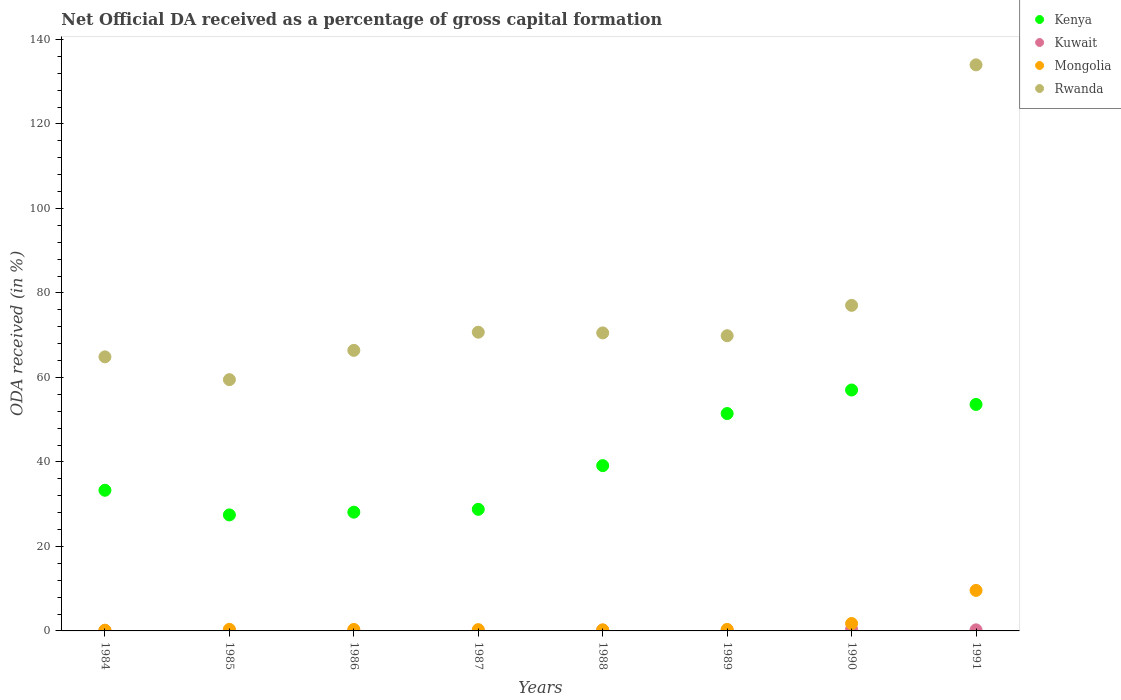How many different coloured dotlines are there?
Offer a terse response. 4. Is the number of dotlines equal to the number of legend labels?
Your answer should be compact. Yes. What is the net ODA received in Kuwait in 1990?
Keep it short and to the point. 0.4. Across all years, what is the maximum net ODA received in Kuwait?
Your answer should be very brief. 0.4. Across all years, what is the minimum net ODA received in Kenya?
Make the answer very short. 27.46. What is the total net ODA received in Kuwait in the graph?
Offer a very short reply. 1.41. What is the difference between the net ODA received in Kuwait in 1984 and that in 1991?
Offer a very short reply. -0.16. What is the difference between the net ODA received in Rwanda in 1989 and the net ODA received in Kuwait in 1986?
Offer a terse response. 69.75. What is the average net ODA received in Kenya per year?
Ensure brevity in your answer.  39.86. In the year 1988, what is the difference between the net ODA received in Kenya and net ODA received in Rwanda?
Offer a terse response. -31.42. What is the ratio of the net ODA received in Rwanda in 1984 to that in 1986?
Offer a very short reply. 0.98. Is the net ODA received in Kenya in 1984 less than that in 1988?
Keep it short and to the point. Yes. Is the difference between the net ODA received in Kenya in 1988 and 1990 greater than the difference between the net ODA received in Rwanda in 1988 and 1990?
Provide a short and direct response. No. What is the difference between the highest and the second highest net ODA received in Kenya?
Your answer should be very brief. 3.41. What is the difference between the highest and the lowest net ODA received in Kenya?
Keep it short and to the point. 29.57. In how many years, is the net ODA received in Kuwait greater than the average net ODA received in Kuwait taken over all years?
Give a very brief answer. 3. Is the sum of the net ODA received in Kenya in 1986 and 1991 greater than the maximum net ODA received in Rwanda across all years?
Your answer should be compact. No. Is it the case that in every year, the sum of the net ODA received in Mongolia and net ODA received in Kenya  is greater than the net ODA received in Rwanda?
Give a very brief answer. No. How many dotlines are there?
Give a very brief answer. 4. How many years are there in the graph?
Provide a short and direct response. 8. Are the values on the major ticks of Y-axis written in scientific E-notation?
Your answer should be compact. No. Does the graph contain any zero values?
Give a very brief answer. No. Does the graph contain grids?
Give a very brief answer. No. Where does the legend appear in the graph?
Provide a succinct answer. Top right. How are the legend labels stacked?
Offer a terse response. Vertical. What is the title of the graph?
Your answer should be compact. Net Official DA received as a percentage of gross capital formation. Does "Gambia, The" appear as one of the legend labels in the graph?
Keep it short and to the point. No. What is the label or title of the Y-axis?
Provide a succinct answer. ODA received (in %). What is the ODA received (in %) of Kenya in 1984?
Offer a terse response. 33.3. What is the ODA received (in %) of Kuwait in 1984?
Offer a terse response. 0.1. What is the ODA received (in %) in Mongolia in 1984?
Your answer should be compact. 0.17. What is the ODA received (in %) in Rwanda in 1984?
Ensure brevity in your answer.  64.87. What is the ODA received (in %) of Kenya in 1985?
Your response must be concise. 27.46. What is the ODA received (in %) in Kuwait in 1985?
Make the answer very short. 0.1. What is the ODA received (in %) of Mongolia in 1985?
Ensure brevity in your answer.  0.38. What is the ODA received (in %) of Rwanda in 1985?
Provide a short and direct response. 59.48. What is the ODA received (in %) in Kenya in 1986?
Your response must be concise. 28.11. What is the ODA received (in %) in Kuwait in 1986?
Offer a terse response. 0.13. What is the ODA received (in %) in Mongolia in 1986?
Offer a very short reply. 0.35. What is the ODA received (in %) of Rwanda in 1986?
Ensure brevity in your answer.  66.41. What is the ODA received (in %) in Kenya in 1987?
Your answer should be compact. 28.78. What is the ODA received (in %) of Kuwait in 1987?
Offer a terse response. 0.09. What is the ODA received (in %) of Mongolia in 1987?
Make the answer very short. 0.3. What is the ODA received (in %) in Rwanda in 1987?
Offer a terse response. 70.71. What is the ODA received (in %) of Kenya in 1988?
Your answer should be compact. 39.13. What is the ODA received (in %) in Kuwait in 1988?
Provide a short and direct response. 0.18. What is the ODA received (in %) of Mongolia in 1988?
Your response must be concise. 0.26. What is the ODA received (in %) in Rwanda in 1988?
Your response must be concise. 70.55. What is the ODA received (in %) of Kenya in 1989?
Your answer should be very brief. 51.46. What is the ODA received (in %) in Kuwait in 1989?
Provide a short and direct response. 0.16. What is the ODA received (in %) of Mongolia in 1989?
Provide a succinct answer. 0.36. What is the ODA received (in %) of Rwanda in 1989?
Give a very brief answer. 69.88. What is the ODA received (in %) of Kenya in 1990?
Give a very brief answer. 57.03. What is the ODA received (in %) of Kuwait in 1990?
Give a very brief answer. 0.4. What is the ODA received (in %) in Mongolia in 1990?
Keep it short and to the point. 1.75. What is the ODA received (in %) in Rwanda in 1990?
Provide a succinct answer. 77.07. What is the ODA received (in %) of Kenya in 1991?
Offer a very short reply. 53.61. What is the ODA received (in %) in Kuwait in 1991?
Ensure brevity in your answer.  0.26. What is the ODA received (in %) of Mongolia in 1991?
Your response must be concise. 9.59. What is the ODA received (in %) of Rwanda in 1991?
Offer a terse response. 134. Across all years, what is the maximum ODA received (in %) in Kenya?
Offer a terse response. 57.03. Across all years, what is the maximum ODA received (in %) of Kuwait?
Keep it short and to the point. 0.4. Across all years, what is the maximum ODA received (in %) of Mongolia?
Provide a short and direct response. 9.59. Across all years, what is the maximum ODA received (in %) of Rwanda?
Provide a succinct answer. 134. Across all years, what is the minimum ODA received (in %) of Kenya?
Offer a very short reply. 27.46. Across all years, what is the minimum ODA received (in %) of Kuwait?
Make the answer very short. 0.09. Across all years, what is the minimum ODA received (in %) in Mongolia?
Offer a terse response. 0.17. Across all years, what is the minimum ODA received (in %) in Rwanda?
Offer a very short reply. 59.48. What is the total ODA received (in %) in Kenya in the graph?
Make the answer very short. 318.88. What is the total ODA received (in %) in Kuwait in the graph?
Your response must be concise. 1.41. What is the total ODA received (in %) in Mongolia in the graph?
Keep it short and to the point. 13.16. What is the total ODA received (in %) in Rwanda in the graph?
Make the answer very short. 612.96. What is the difference between the ODA received (in %) in Kenya in 1984 and that in 1985?
Your response must be concise. 5.84. What is the difference between the ODA received (in %) of Kuwait in 1984 and that in 1985?
Keep it short and to the point. -0.01. What is the difference between the ODA received (in %) in Mongolia in 1984 and that in 1985?
Offer a very short reply. -0.2. What is the difference between the ODA received (in %) of Rwanda in 1984 and that in 1985?
Offer a terse response. 5.4. What is the difference between the ODA received (in %) of Kenya in 1984 and that in 1986?
Ensure brevity in your answer.  5.19. What is the difference between the ODA received (in %) of Kuwait in 1984 and that in 1986?
Give a very brief answer. -0.03. What is the difference between the ODA received (in %) of Mongolia in 1984 and that in 1986?
Ensure brevity in your answer.  -0.18. What is the difference between the ODA received (in %) of Rwanda in 1984 and that in 1986?
Make the answer very short. -1.54. What is the difference between the ODA received (in %) in Kenya in 1984 and that in 1987?
Provide a succinct answer. 4.52. What is the difference between the ODA received (in %) in Kuwait in 1984 and that in 1987?
Your answer should be very brief. 0.01. What is the difference between the ODA received (in %) in Mongolia in 1984 and that in 1987?
Keep it short and to the point. -0.13. What is the difference between the ODA received (in %) in Rwanda in 1984 and that in 1987?
Keep it short and to the point. -5.84. What is the difference between the ODA received (in %) in Kenya in 1984 and that in 1988?
Make the answer very short. -5.83. What is the difference between the ODA received (in %) of Kuwait in 1984 and that in 1988?
Offer a very short reply. -0.08. What is the difference between the ODA received (in %) in Mongolia in 1984 and that in 1988?
Offer a terse response. -0.08. What is the difference between the ODA received (in %) in Rwanda in 1984 and that in 1988?
Your answer should be very brief. -5.67. What is the difference between the ODA received (in %) in Kenya in 1984 and that in 1989?
Your answer should be compact. -18.16. What is the difference between the ODA received (in %) of Kuwait in 1984 and that in 1989?
Your answer should be compact. -0.06. What is the difference between the ODA received (in %) of Mongolia in 1984 and that in 1989?
Provide a succinct answer. -0.18. What is the difference between the ODA received (in %) of Rwanda in 1984 and that in 1989?
Offer a very short reply. -5. What is the difference between the ODA received (in %) in Kenya in 1984 and that in 1990?
Provide a short and direct response. -23.73. What is the difference between the ODA received (in %) in Kuwait in 1984 and that in 1990?
Your response must be concise. -0.3. What is the difference between the ODA received (in %) of Mongolia in 1984 and that in 1990?
Your answer should be compact. -1.58. What is the difference between the ODA received (in %) in Rwanda in 1984 and that in 1990?
Your answer should be very brief. -12.19. What is the difference between the ODA received (in %) in Kenya in 1984 and that in 1991?
Offer a very short reply. -20.31. What is the difference between the ODA received (in %) of Kuwait in 1984 and that in 1991?
Give a very brief answer. -0.16. What is the difference between the ODA received (in %) in Mongolia in 1984 and that in 1991?
Provide a short and direct response. -9.41. What is the difference between the ODA received (in %) in Rwanda in 1984 and that in 1991?
Keep it short and to the point. -69.12. What is the difference between the ODA received (in %) of Kenya in 1985 and that in 1986?
Provide a succinct answer. -0.65. What is the difference between the ODA received (in %) in Kuwait in 1985 and that in 1986?
Offer a very short reply. -0.02. What is the difference between the ODA received (in %) of Mongolia in 1985 and that in 1986?
Your answer should be very brief. 0.02. What is the difference between the ODA received (in %) in Rwanda in 1985 and that in 1986?
Ensure brevity in your answer.  -6.93. What is the difference between the ODA received (in %) of Kenya in 1985 and that in 1987?
Your response must be concise. -1.32. What is the difference between the ODA received (in %) of Kuwait in 1985 and that in 1987?
Ensure brevity in your answer.  0.02. What is the difference between the ODA received (in %) of Mongolia in 1985 and that in 1987?
Give a very brief answer. 0.07. What is the difference between the ODA received (in %) of Rwanda in 1985 and that in 1987?
Provide a succinct answer. -11.23. What is the difference between the ODA received (in %) of Kenya in 1985 and that in 1988?
Provide a succinct answer. -11.67. What is the difference between the ODA received (in %) of Kuwait in 1985 and that in 1988?
Offer a very short reply. -0.08. What is the difference between the ODA received (in %) in Mongolia in 1985 and that in 1988?
Keep it short and to the point. 0.12. What is the difference between the ODA received (in %) of Rwanda in 1985 and that in 1988?
Offer a terse response. -11.07. What is the difference between the ODA received (in %) of Kenya in 1985 and that in 1989?
Offer a terse response. -24. What is the difference between the ODA received (in %) of Kuwait in 1985 and that in 1989?
Your answer should be compact. -0.05. What is the difference between the ODA received (in %) of Mongolia in 1985 and that in 1989?
Keep it short and to the point. 0.02. What is the difference between the ODA received (in %) of Rwanda in 1985 and that in 1989?
Give a very brief answer. -10.4. What is the difference between the ODA received (in %) of Kenya in 1985 and that in 1990?
Your answer should be very brief. -29.57. What is the difference between the ODA received (in %) of Kuwait in 1985 and that in 1990?
Ensure brevity in your answer.  -0.29. What is the difference between the ODA received (in %) of Mongolia in 1985 and that in 1990?
Provide a short and direct response. -1.38. What is the difference between the ODA received (in %) of Rwanda in 1985 and that in 1990?
Offer a terse response. -17.59. What is the difference between the ODA received (in %) of Kenya in 1985 and that in 1991?
Provide a short and direct response. -26.15. What is the difference between the ODA received (in %) in Kuwait in 1985 and that in 1991?
Your response must be concise. -0.15. What is the difference between the ODA received (in %) of Mongolia in 1985 and that in 1991?
Give a very brief answer. -9.21. What is the difference between the ODA received (in %) in Rwanda in 1985 and that in 1991?
Provide a short and direct response. -74.52. What is the difference between the ODA received (in %) of Kenya in 1986 and that in 1987?
Your answer should be very brief. -0.67. What is the difference between the ODA received (in %) of Kuwait in 1986 and that in 1987?
Offer a very short reply. 0.04. What is the difference between the ODA received (in %) in Mongolia in 1986 and that in 1987?
Your answer should be compact. 0.05. What is the difference between the ODA received (in %) in Rwanda in 1986 and that in 1987?
Give a very brief answer. -4.3. What is the difference between the ODA received (in %) of Kenya in 1986 and that in 1988?
Provide a short and direct response. -11.02. What is the difference between the ODA received (in %) in Kuwait in 1986 and that in 1988?
Provide a short and direct response. -0.06. What is the difference between the ODA received (in %) in Mongolia in 1986 and that in 1988?
Give a very brief answer. 0.1. What is the difference between the ODA received (in %) of Rwanda in 1986 and that in 1988?
Offer a very short reply. -4.13. What is the difference between the ODA received (in %) in Kenya in 1986 and that in 1989?
Provide a short and direct response. -23.35. What is the difference between the ODA received (in %) of Kuwait in 1986 and that in 1989?
Ensure brevity in your answer.  -0.03. What is the difference between the ODA received (in %) in Mongolia in 1986 and that in 1989?
Ensure brevity in your answer.  -0. What is the difference between the ODA received (in %) of Rwanda in 1986 and that in 1989?
Your response must be concise. -3.46. What is the difference between the ODA received (in %) in Kenya in 1986 and that in 1990?
Offer a terse response. -28.92. What is the difference between the ODA received (in %) in Kuwait in 1986 and that in 1990?
Give a very brief answer. -0.27. What is the difference between the ODA received (in %) of Mongolia in 1986 and that in 1990?
Give a very brief answer. -1.4. What is the difference between the ODA received (in %) in Rwanda in 1986 and that in 1990?
Provide a short and direct response. -10.65. What is the difference between the ODA received (in %) of Kenya in 1986 and that in 1991?
Provide a short and direct response. -25.5. What is the difference between the ODA received (in %) of Kuwait in 1986 and that in 1991?
Offer a terse response. -0.13. What is the difference between the ODA received (in %) in Mongolia in 1986 and that in 1991?
Provide a succinct answer. -9.24. What is the difference between the ODA received (in %) in Rwanda in 1986 and that in 1991?
Offer a very short reply. -67.58. What is the difference between the ODA received (in %) of Kenya in 1987 and that in 1988?
Your answer should be very brief. -10.35. What is the difference between the ODA received (in %) in Kuwait in 1987 and that in 1988?
Make the answer very short. -0.1. What is the difference between the ODA received (in %) in Mongolia in 1987 and that in 1988?
Your answer should be very brief. 0.05. What is the difference between the ODA received (in %) of Rwanda in 1987 and that in 1988?
Keep it short and to the point. 0.17. What is the difference between the ODA received (in %) in Kenya in 1987 and that in 1989?
Offer a very short reply. -22.68. What is the difference between the ODA received (in %) in Kuwait in 1987 and that in 1989?
Keep it short and to the point. -0.07. What is the difference between the ODA received (in %) in Mongolia in 1987 and that in 1989?
Make the answer very short. -0.05. What is the difference between the ODA received (in %) in Rwanda in 1987 and that in 1989?
Your answer should be very brief. 0.83. What is the difference between the ODA received (in %) in Kenya in 1987 and that in 1990?
Your answer should be very brief. -28.25. What is the difference between the ODA received (in %) of Kuwait in 1987 and that in 1990?
Ensure brevity in your answer.  -0.31. What is the difference between the ODA received (in %) in Mongolia in 1987 and that in 1990?
Provide a succinct answer. -1.45. What is the difference between the ODA received (in %) in Rwanda in 1987 and that in 1990?
Offer a very short reply. -6.36. What is the difference between the ODA received (in %) of Kenya in 1987 and that in 1991?
Give a very brief answer. -24.83. What is the difference between the ODA received (in %) of Kuwait in 1987 and that in 1991?
Your answer should be very brief. -0.17. What is the difference between the ODA received (in %) in Mongolia in 1987 and that in 1991?
Provide a succinct answer. -9.28. What is the difference between the ODA received (in %) in Rwanda in 1987 and that in 1991?
Ensure brevity in your answer.  -63.28. What is the difference between the ODA received (in %) in Kenya in 1988 and that in 1989?
Provide a short and direct response. -12.33. What is the difference between the ODA received (in %) of Kuwait in 1988 and that in 1989?
Your answer should be compact. 0.03. What is the difference between the ODA received (in %) of Mongolia in 1988 and that in 1989?
Give a very brief answer. -0.1. What is the difference between the ODA received (in %) of Rwanda in 1988 and that in 1989?
Give a very brief answer. 0.67. What is the difference between the ODA received (in %) of Kenya in 1988 and that in 1990?
Give a very brief answer. -17.9. What is the difference between the ODA received (in %) in Kuwait in 1988 and that in 1990?
Offer a very short reply. -0.21. What is the difference between the ODA received (in %) in Mongolia in 1988 and that in 1990?
Your answer should be very brief. -1.5. What is the difference between the ODA received (in %) of Rwanda in 1988 and that in 1990?
Provide a short and direct response. -6.52. What is the difference between the ODA received (in %) in Kenya in 1988 and that in 1991?
Offer a very short reply. -14.48. What is the difference between the ODA received (in %) of Kuwait in 1988 and that in 1991?
Offer a very short reply. -0.07. What is the difference between the ODA received (in %) in Mongolia in 1988 and that in 1991?
Make the answer very short. -9.33. What is the difference between the ODA received (in %) of Rwanda in 1988 and that in 1991?
Keep it short and to the point. -63.45. What is the difference between the ODA received (in %) of Kenya in 1989 and that in 1990?
Provide a short and direct response. -5.57. What is the difference between the ODA received (in %) in Kuwait in 1989 and that in 1990?
Ensure brevity in your answer.  -0.24. What is the difference between the ODA received (in %) in Mongolia in 1989 and that in 1990?
Offer a very short reply. -1.4. What is the difference between the ODA received (in %) in Rwanda in 1989 and that in 1990?
Give a very brief answer. -7.19. What is the difference between the ODA received (in %) of Kenya in 1989 and that in 1991?
Make the answer very short. -2.15. What is the difference between the ODA received (in %) in Kuwait in 1989 and that in 1991?
Provide a short and direct response. -0.1. What is the difference between the ODA received (in %) in Mongolia in 1989 and that in 1991?
Your answer should be very brief. -9.23. What is the difference between the ODA received (in %) in Rwanda in 1989 and that in 1991?
Ensure brevity in your answer.  -64.12. What is the difference between the ODA received (in %) of Kenya in 1990 and that in 1991?
Provide a succinct answer. 3.41. What is the difference between the ODA received (in %) of Kuwait in 1990 and that in 1991?
Offer a terse response. 0.14. What is the difference between the ODA received (in %) in Mongolia in 1990 and that in 1991?
Your answer should be compact. -7.84. What is the difference between the ODA received (in %) of Rwanda in 1990 and that in 1991?
Offer a very short reply. -56.93. What is the difference between the ODA received (in %) in Kenya in 1984 and the ODA received (in %) in Kuwait in 1985?
Offer a terse response. 33.19. What is the difference between the ODA received (in %) in Kenya in 1984 and the ODA received (in %) in Mongolia in 1985?
Provide a short and direct response. 32.92. What is the difference between the ODA received (in %) of Kenya in 1984 and the ODA received (in %) of Rwanda in 1985?
Offer a terse response. -26.18. What is the difference between the ODA received (in %) in Kuwait in 1984 and the ODA received (in %) in Mongolia in 1985?
Your response must be concise. -0.28. What is the difference between the ODA received (in %) of Kuwait in 1984 and the ODA received (in %) of Rwanda in 1985?
Your answer should be very brief. -59.38. What is the difference between the ODA received (in %) of Mongolia in 1984 and the ODA received (in %) of Rwanda in 1985?
Keep it short and to the point. -59.3. What is the difference between the ODA received (in %) in Kenya in 1984 and the ODA received (in %) in Kuwait in 1986?
Ensure brevity in your answer.  33.17. What is the difference between the ODA received (in %) in Kenya in 1984 and the ODA received (in %) in Mongolia in 1986?
Make the answer very short. 32.95. What is the difference between the ODA received (in %) of Kenya in 1984 and the ODA received (in %) of Rwanda in 1986?
Provide a succinct answer. -33.12. What is the difference between the ODA received (in %) in Kuwait in 1984 and the ODA received (in %) in Mongolia in 1986?
Offer a very short reply. -0.25. What is the difference between the ODA received (in %) in Kuwait in 1984 and the ODA received (in %) in Rwanda in 1986?
Provide a succinct answer. -66.32. What is the difference between the ODA received (in %) in Mongolia in 1984 and the ODA received (in %) in Rwanda in 1986?
Keep it short and to the point. -66.24. What is the difference between the ODA received (in %) of Kenya in 1984 and the ODA received (in %) of Kuwait in 1987?
Offer a terse response. 33.21. What is the difference between the ODA received (in %) in Kenya in 1984 and the ODA received (in %) in Mongolia in 1987?
Provide a succinct answer. 32.99. What is the difference between the ODA received (in %) in Kenya in 1984 and the ODA received (in %) in Rwanda in 1987?
Offer a terse response. -37.41. What is the difference between the ODA received (in %) of Kuwait in 1984 and the ODA received (in %) of Mongolia in 1987?
Provide a short and direct response. -0.21. What is the difference between the ODA received (in %) in Kuwait in 1984 and the ODA received (in %) in Rwanda in 1987?
Your answer should be compact. -70.61. What is the difference between the ODA received (in %) in Mongolia in 1984 and the ODA received (in %) in Rwanda in 1987?
Provide a short and direct response. -70.54. What is the difference between the ODA received (in %) in Kenya in 1984 and the ODA received (in %) in Kuwait in 1988?
Make the answer very short. 33.12. What is the difference between the ODA received (in %) in Kenya in 1984 and the ODA received (in %) in Mongolia in 1988?
Offer a very short reply. 33.04. What is the difference between the ODA received (in %) in Kenya in 1984 and the ODA received (in %) in Rwanda in 1988?
Offer a very short reply. -37.25. What is the difference between the ODA received (in %) of Kuwait in 1984 and the ODA received (in %) of Mongolia in 1988?
Ensure brevity in your answer.  -0.16. What is the difference between the ODA received (in %) in Kuwait in 1984 and the ODA received (in %) in Rwanda in 1988?
Your answer should be compact. -70.45. What is the difference between the ODA received (in %) of Mongolia in 1984 and the ODA received (in %) of Rwanda in 1988?
Your answer should be very brief. -70.37. What is the difference between the ODA received (in %) in Kenya in 1984 and the ODA received (in %) in Kuwait in 1989?
Offer a very short reply. 33.14. What is the difference between the ODA received (in %) of Kenya in 1984 and the ODA received (in %) of Mongolia in 1989?
Keep it short and to the point. 32.94. What is the difference between the ODA received (in %) in Kenya in 1984 and the ODA received (in %) in Rwanda in 1989?
Offer a very short reply. -36.58. What is the difference between the ODA received (in %) in Kuwait in 1984 and the ODA received (in %) in Mongolia in 1989?
Provide a succinct answer. -0.26. What is the difference between the ODA received (in %) of Kuwait in 1984 and the ODA received (in %) of Rwanda in 1989?
Provide a succinct answer. -69.78. What is the difference between the ODA received (in %) of Mongolia in 1984 and the ODA received (in %) of Rwanda in 1989?
Your answer should be compact. -69.7. What is the difference between the ODA received (in %) in Kenya in 1984 and the ODA received (in %) in Kuwait in 1990?
Provide a succinct answer. 32.9. What is the difference between the ODA received (in %) in Kenya in 1984 and the ODA received (in %) in Mongolia in 1990?
Provide a succinct answer. 31.54. What is the difference between the ODA received (in %) in Kenya in 1984 and the ODA received (in %) in Rwanda in 1990?
Make the answer very short. -43.77. What is the difference between the ODA received (in %) in Kuwait in 1984 and the ODA received (in %) in Mongolia in 1990?
Keep it short and to the point. -1.66. What is the difference between the ODA received (in %) of Kuwait in 1984 and the ODA received (in %) of Rwanda in 1990?
Your answer should be very brief. -76.97. What is the difference between the ODA received (in %) of Mongolia in 1984 and the ODA received (in %) of Rwanda in 1990?
Your answer should be very brief. -76.89. What is the difference between the ODA received (in %) in Kenya in 1984 and the ODA received (in %) in Kuwait in 1991?
Provide a succinct answer. 33.04. What is the difference between the ODA received (in %) of Kenya in 1984 and the ODA received (in %) of Mongolia in 1991?
Offer a very short reply. 23.71. What is the difference between the ODA received (in %) of Kenya in 1984 and the ODA received (in %) of Rwanda in 1991?
Keep it short and to the point. -100.7. What is the difference between the ODA received (in %) of Kuwait in 1984 and the ODA received (in %) of Mongolia in 1991?
Make the answer very short. -9.49. What is the difference between the ODA received (in %) in Kuwait in 1984 and the ODA received (in %) in Rwanda in 1991?
Keep it short and to the point. -133.9. What is the difference between the ODA received (in %) of Mongolia in 1984 and the ODA received (in %) of Rwanda in 1991?
Give a very brief answer. -133.82. What is the difference between the ODA received (in %) in Kenya in 1985 and the ODA received (in %) in Kuwait in 1986?
Your response must be concise. 27.34. What is the difference between the ODA received (in %) of Kenya in 1985 and the ODA received (in %) of Mongolia in 1986?
Your response must be concise. 27.11. What is the difference between the ODA received (in %) in Kenya in 1985 and the ODA received (in %) in Rwanda in 1986?
Give a very brief answer. -38.95. What is the difference between the ODA received (in %) in Kuwait in 1985 and the ODA received (in %) in Mongolia in 1986?
Your answer should be compact. -0.25. What is the difference between the ODA received (in %) in Kuwait in 1985 and the ODA received (in %) in Rwanda in 1986?
Offer a very short reply. -66.31. What is the difference between the ODA received (in %) in Mongolia in 1985 and the ODA received (in %) in Rwanda in 1986?
Your answer should be compact. -66.04. What is the difference between the ODA received (in %) in Kenya in 1985 and the ODA received (in %) in Kuwait in 1987?
Offer a very short reply. 27.37. What is the difference between the ODA received (in %) of Kenya in 1985 and the ODA received (in %) of Mongolia in 1987?
Give a very brief answer. 27.16. What is the difference between the ODA received (in %) in Kenya in 1985 and the ODA received (in %) in Rwanda in 1987?
Give a very brief answer. -43.25. What is the difference between the ODA received (in %) of Kuwait in 1985 and the ODA received (in %) of Mongolia in 1987?
Provide a short and direct response. -0.2. What is the difference between the ODA received (in %) of Kuwait in 1985 and the ODA received (in %) of Rwanda in 1987?
Ensure brevity in your answer.  -70.61. What is the difference between the ODA received (in %) in Mongolia in 1985 and the ODA received (in %) in Rwanda in 1987?
Ensure brevity in your answer.  -70.33. What is the difference between the ODA received (in %) of Kenya in 1985 and the ODA received (in %) of Kuwait in 1988?
Your answer should be compact. 27.28. What is the difference between the ODA received (in %) of Kenya in 1985 and the ODA received (in %) of Mongolia in 1988?
Give a very brief answer. 27.21. What is the difference between the ODA received (in %) of Kenya in 1985 and the ODA received (in %) of Rwanda in 1988?
Your answer should be very brief. -43.08. What is the difference between the ODA received (in %) in Kuwait in 1985 and the ODA received (in %) in Mongolia in 1988?
Offer a terse response. -0.15. What is the difference between the ODA received (in %) in Kuwait in 1985 and the ODA received (in %) in Rwanda in 1988?
Provide a succinct answer. -70.44. What is the difference between the ODA received (in %) in Mongolia in 1985 and the ODA received (in %) in Rwanda in 1988?
Make the answer very short. -70.17. What is the difference between the ODA received (in %) of Kenya in 1985 and the ODA received (in %) of Kuwait in 1989?
Offer a very short reply. 27.3. What is the difference between the ODA received (in %) of Kenya in 1985 and the ODA received (in %) of Mongolia in 1989?
Your response must be concise. 27.11. What is the difference between the ODA received (in %) of Kenya in 1985 and the ODA received (in %) of Rwanda in 1989?
Your answer should be compact. -42.42. What is the difference between the ODA received (in %) in Kuwait in 1985 and the ODA received (in %) in Mongolia in 1989?
Your response must be concise. -0.25. What is the difference between the ODA received (in %) of Kuwait in 1985 and the ODA received (in %) of Rwanda in 1989?
Make the answer very short. -69.77. What is the difference between the ODA received (in %) in Mongolia in 1985 and the ODA received (in %) in Rwanda in 1989?
Your answer should be very brief. -69.5. What is the difference between the ODA received (in %) in Kenya in 1985 and the ODA received (in %) in Kuwait in 1990?
Offer a very short reply. 27.07. What is the difference between the ODA received (in %) of Kenya in 1985 and the ODA received (in %) of Mongolia in 1990?
Offer a very short reply. 25.71. What is the difference between the ODA received (in %) of Kenya in 1985 and the ODA received (in %) of Rwanda in 1990?
Offer a very short reply. -49.6. What is the difference between the ODA received (in %) of Kuwait in 1985 and the ODA received (in %) of Mongolia in 1990?
Make the answer very short. -1.65. What is the difference between the ODA received (in %) in Kuwait in 1985 and the ODA received (in %) in Rwanda in 1990?
Your response must be concise. -76.96. What is the difference between the ODA received (in %) of Mongolia in 1985 and the ODA received (in %) of Rwanda in 1990?
Your answer should be compact. -76.69. What is the difference between the ODA received (in %) in Kenya in 1985 and the ODA received (in %) in Kuwait in 1991?
Make the answer very short. 27.21. What is the difference between the ODA received (in %) of Kenya in 1985 and the ODA received (in %) of Mongolia in 1991?
Give a very brief answer. 17.87. What is the difference between the ODA received (in %) of Kenya in 1985 and the ODA received (in %) of Rwanda in 1991?
Provide a succinct answer. -106.53. What is the difference between the ODA received (in %) in Kuwait in 1985 and the ODA received (in %) in Mongolia in 1991?
Offer a very short reply. -9.49. What is the difference between the ODA received (in %) of Kuwait in 1985 and the ODA received (in %) of Rwanda in 1991?
Offer a very short reply. -133.89. What is the difference between the ODA received (in %) in Mongolia in 1985 and the ODA received (in %) in Rwanda in 1991?
Give a very brief answer. -133.62. What is the difference between the ODA received (in %) in Kenya in 1986 and the ODA received (in %) in Kuwait in 1987?
Provide a succinct answer. 28.02. What is the difference between the ODA received (in %) of Kenya in 1986 and the ODA received (in %) of Mongolia in 1987?
Give a very brief answer. 27.81. What is the difference between the ODA received (in %) in Kenya in 1986 and the ODA received (in %) in Rwanda in 1987?
Provide a short and direct response. -42.6. What is the difference between the ODA received (in %) in Kuwait in 1986 and the ODA received (in %) in Mongolia in 1987?
Offer a terse response. -0.18. What is the difference between the ODA received (in %) in Kuwait in 1986 and the ODA received (in %) in Rwanda in 1987?
Provide a short and direct response. -70.59. What is the difference between the ODA received (in %) in Mongolia in 1986 and the ODA received (in %) in Rwanda in 1987?
Your response must be concise. -70.36. What is the difference between the ODA received (in %) in Kenya in 1986 and the ODA received (in %) in Kuwait in 1988?
Your response must be concise. 27.93. What is the difference between the ODA received (in %) in Kenya in 1986 and the ODA received (in %) in Mongolia in 1988?
Keep it short and to the point. 27.85. What is the difference between the ODA received (in %) in Kenya in 1986 and the ODA received (in %) in Rwanda in 1988?
Your answer should be very brief. -42.44. What is the difference between the ODA received (in %) of Kuwait in 1986 and the ODA received (in %) of Mongolia in 1988?
Your response must be concise. -0.13. What is the difference between the ODA received (in %) of Kuwait in 1986 and the ODA received (in %) of Rwanda in 1988?
Your response must be concise. -70.42. What is the difference between the ODA received (in %) of Mongolia in 1986 and the ODA received (in %) of Rwanda in 1988?
Your answer should be very brief. -70.19. What is the difference between the ODA received (in %) of Kenya in 1986 and the ODA received (in %) of Kuwait in 1989?
Offer a terse response. 27.95. What is the difference between the ODA received (in %) of Kenya in 1986 and the ODA received (in %) of Mongolia in 1989?
Keep it short and to the point. 27.75. What is the difference between the ODA received (in %) of Kenya in 1986 and the ODA received (in %) of Rwanda in 1989?
Give a very brief answer. -41.77. What is the difference between the ODA received (in %) in Kuwait in 1986 and the ODA received (in %) in Mongolia in 1989?
Make the answer very short. -0.23. What is the difference between the ODA received (in %) of Kuwait in 1986 and the ODA received (in %) of Rwanda in 1989?
Provide a succinct answer. -69.75. What is the difference between the ODA received (in %) of Mongolia in 1986 and the ODA received (in %) of Rwanda in 1989?
Your response must be concise. -69.52. What is the difference between the ODA received (in %) in Kenya in 1986 and the ODA received (in %) in Kuwait in 1990?
Make the answer very short. 27.71. What is the difference between the ODA received (in %) of Kenya in 1986 and the ODA received (in %) of Mongolia in 1990?
Provide a short and direct response. 26.36. What is the difference between the ODA received (in %) of Kenya in 1986 and the ODA received (in %) of Rwanda in 1990?
Your response must be concise. -48.96. What is the difference between the ODA received (in %) in Kuwait in 1986 and the ODA received (in %) in Mongolia in 1990?
Your answer should be very brief. -1.63. What is the difference between the ODA received (in %) in Kuwait in 1986 and the ODA received (in %) in Rwanda in 1990?
Give a very brief answer. -76.94. What is the difference between the ODA received (in %) of Mongolia in 1986 and the ODA received (in %) of Rwanda in 1990?
Ensure brevity in your answer.  -76.71. What is the difference between the ODA received (in %) of Kenya in 1986 and the ODA received (in %) of Kuwait in 1991?
Your answer should be very brief. 27.85. What is the difference between the ODA received (in %) in Kenya in 1986 and the ODA received (in %) in Mongolia in 1991?
Provide a succinct answer. 18.52. What is the difference between the ODA received (in %) in Kenya in 1986 and the ODA received (in %) in Rwanda in 1991?
Your answer should be compact. -105.89. What is the difference between the ODA received (in %) of Kuwait in 1986 and the ODA received (in %) of Mongolia in 1991?
Keep it short and to the point. -9.46. What is the difference between the ODA received (in %) of Kuwait in 1986 and the ODA received (in %) of Rwanda in 1991?
Keep it short and to the point. -133.87. What is the difference between the ODA received (in %) of Mongolia in 1986 and the ODA received (in %) of Rwanda in 1991?
Make the answer very short. -133.64. What is the difference between the ODA received (in %) in Kenya in 1987 and the ODA received (in %) in Kuwait in 1988?
Your answer should be very brief. 28.6. What is the difference between the ODA received (in %) in Kenya in 1987 and the ODA received (in %) in Mongolia in 1988?
Offer a terse response. 28.53. What is the difference between the ODA received (in %) of Kenya in 1987 and the ODA received (in %) of Rwanda in 1988?
Your answer should be very brief. -41.76. What is the difference between the ODA received (in %) in Kuwait in 1987 and the ODA received (in %) in Mongolia in 1988?
Your response must be concise. -0.17. What is the difference between the ODA received (in %) of Kuwait in 1987 and the ODA received (in %) of Rwanda in 1988?
Provide a succinct answer. -70.46. What is the difference between the ODA received (in %) in Mongolia in 1987 and the ODA received (in %) in Rwanda in 1988?
Keep it short and to the point. -70.24. What is the difference between the ODA received (in %) of Kenya in 1987 and the ODA received (in %) of Kuwait in 1989?
Your response must be concise. 28.62. What is the difference between the ODA received (in %) in Kenya in 1987 and the ODA received (in %) in Mongolia in 1989?
Offer a terse response. 28.42. What is the difference between the ODA received (in %) of Kenya in 1987 and the ODA received (in %) of Rwanda in 1989?
Your answer should be compact. -41.1. What is the difference between the ODA received (in %) in Kuwait in 1987 and the ODA received (in %) in Mongolia in 1989?
Your answer should be very brief. -0.27. What is the difference between the ODA received (in %) in Kuwait in 1987 and the ODA received (in %) in Rwanda in 1989?
Make the answer very short. -69.79. What is the difference between the ODA received (in %) of Mongolia in 1987 and the ODA received (in %) of Rwanda in 1989?
Your response must be concise. -69.57. What is the difference between the ODA received (in %) of Kenya in 1987 and the ODA received (in %) of Kuwait in 1990?
Your answer should be compact. 28.39. What is the difference between the ODA received (in %) of Kenya in 1987 and the ODA received (in %) of Mongolia in 1990?
Keep it short and to the point. 27.03. What is the difference between the ODA received (in %) in Kenya in 1987 and the ODA received (in %) in Rwanda in 1990?
Your response must be concise. -48.28. What is the difference between the ODA received (in %) of Kuwait in 1987 and the ODA received (in %) of Mongolia in 1990?
Make the answer very short. -1.67. What is the difference between the ODA received (in %) of Kuwait in 1987 and the ODA received (in %) of Rwanda in 1990?
Your answer should be compact. -76.98. What is the difference between the ODA received (in %) of Mongolia in 1987 and the ODA received (in %) of Rwanda in 1990?
Give a very brief answer. -76.76. What is the difference between the ODA received (in %) of Kenya in 1987 and the ODA received (in %) of Kuwait in 1991?
Offer a terse response. 28.53. What is the difference between the ODA received (in %) in Kenya in 1987 and the ODA received (in %) in Mongolia in 1991?
Make the answer very short. 19.19. What is the difference between the ODA received (in %) in Kenya in 1987 and the ODA received (in %) in Rwanda in 1991?
Your answer should be very brief. -105.21. What is the difference between the ODA received (in %) of Kuwait in 1987 and the ODA received (in %) of Mongolia in 1991?
Offer a terse response. -9.5. What is the difference between the ODA received (in %) of Kuwait in 1987 and the ODA received (in %) of Rwanda in 1991?
Make the answer very short. -133.91. What is the difference between the ODA received (in %) in Mongolia in 1987 and the ODA received (in %) in Rwanda in 1991?
Ensure brevity in your answer.  -133.69. What is the difference between the ODA received (in %) of Kenya in 1988 and the ODA received (in %) of Kuwait in 1989?
Provide a succinct answer. 38.97. What is the difference between the ODA received (in %) of Kenya in 1988 and the ODA received (in %) of Mongolia in 1989?
Offer a very short reply. 38.77. What is the difference between the ODA received (in %) in Kenya in 1988 and the ODA received (in %) in Rwanda in 1989?
Your response must be concise. -30.75. What is the difference between the ODA received (in %) of Kuwait in 1988 and the ODA received (in %) of Mongolia in 1989?
Ensure brevity in your answer.  -0.17. What is the difference between the ODA received (in %) in Kuwait in 1988 and the ODA received (in %) in Rwanda in 1989?
Provide a succinct answer. -69.69. What is the difference between the ODA received (in %) of Mongolia in 1988 and the ODA received (in %) of Rwanda in 1989?
Ensure brevity in your answer.  -69.62. What is the difference between the ODA received (in %) in Kenya in 1988 and the ODA received (in %) in Kuwait in 1990?
Give a very brief answer. 38.73. What is the difference between the ODA received (in %) of Kenya in 1988 and the ODA received (in %) of Mongolia in 1990?
Ensure brevity in your answer.  37.38. What is the difference between the ODA received (in %) in Kenya in 1988 and the ODA received (in %) in Rwanda in 1990?
Your response must be concise. -37.94. What is the difference between the ODA received (in %) in Kuwait in 1988 and the ODA received (in %) in Mongolia in 1990?
Your answer should be compact. -1.57. What is the difference between the ODA received (in %) of Kuwait in 1988 and the ODA received (in %) of Rwanda in 1990?
Your response must be concise. -76.88. What is the difference between the ODA received (in %) of Mongolia in 1988 and the ODA received (in %) of Rwanda in 1990?
Offer a terse response. -76.81. What is the difference between the ODA received (in %) in Kenya in 1988 and the ODA received (in %) in Kuwait in 1991?
Offer a very short reply. 38.87. What is the difference between the ODA received (in %) of Kenya in 1988 and the ODA received (in %) of Mongolia in 1991?
Your response must be concise. 29.54. What is the difference between the ODA received (in %) in Kenya in 1988 and the ODA received (in %) in Rwanda in 1991?
Keep it short and to the point. -94.87. What is the difference between the ODA received (in %) in Kuwait in 1988 and the ODA received (in %) in Mongolia in 1991?
Provide a short and direct response. -9.41. What is the difference between the ODA received (in %) of Kuwait in 1988 and the ODA received (in %) of Rwanda in 1991?
Your answer should be very brief. -133.81. What is the difference between the ODA received (in %) in Mongolia in 1988 and the ODA received (in %) in Rwanda in 1991?
Offer a terse response. -133.74. What is the difference between the ODA received (in %) of Kenya in 1989 and the ODA received (in %) of Kuwait in 1990?
Provide a short and direct response. 51.06. What is the difference between the ODA received (in %) in Kenya in 1989 and the ODA received (in %) in Mongolia in 1990?
Ensure brevity in your answer.  49.7. What is the difference between the ODA received (in %) in Kenya in 1989 and the ODA received (in %) in Rwanda in 1990?
Make the answer very short. -25.61. What is the difference between the ODA received (in %) in Kuwait in 1989 and the ODA received (in %) in Mongolia in 1990?
Your response must be concise. -1.6. What is the difference between the ODA received (in %) in Kuwait in 1989 and the ODA received (in %) in Rwanda in 1990?
Offer a very short reply. -76.91. What is the difference between the ODA received (in %) in Mongolia in 1989 and the ODA received (in %) in Rwanda in 1990?
Provide a short and direct response. -76.71. What is the difference between the ODA received (in %) in Kenya in 1989 and the ODA received (in %) in Kuwait in 1991?
Your answer should be very brief. 51.2. What is the difference between the ODA received (in %) of Kenya in 1989 and the ODA received (in %) of Mongolia in 1991?
Ensure brevity in your answer.  41.87. What is the difference between the ODA received (in %) of Kenya in 1989 and the ODA received (in %) of Rwanda in 1991?
Offer a terse response. -82.54. What is the difference between the ODA received (in %) of Kuwait in 1989 and the ODA received (in %) of Mongolia in 1991?
Provide a short and direct response. -9.43. What is the difference between the ODA received (in %) of Kuwait in 1989 and the ODA received (in %) of Rwanda in 1991?
Your response must be concise. -133.84. What is the difference between the ODA received (in %) of Mongolia in 1989 and the ODA received (in %) of Rwanda in 1991?
Provide a short and direct response. -133.64. What is the difference between the ODA received (in %) in Kenya in 1990 and the ODA received (in %) in Kuwait in 1991?
Make the answer very short. 56.77. What is the difference between the ODA received (in %) in Kenya in 1990 and the ODA received (in %) in Mongolia in 1991?
Keep it short and to the point. 47.44. What is the difference between the ODA received (in %) of Kenya in 1990 and the ODA received (in %) of Rwanda in 1991?
Give a very brief answer. -76.97. What is the difference between the ODA received (in %) in Kuwait in 1990 and the ODA received (in %) in Mongolia in 1991?
Ensure brevity in your answer.  -9.19. What is the difference between the ODA received (in %) in Kuwait in 1990 and the ODA received (in %) in Rwanda in 1991?
Make the answer very short. -133.6. What is the difference between the ODA received (in %) of Mongolia in 1990 and the ODA received (in %) of Rwanda in 1991?
Give a very brief answer. -132.24. What is the average ODA received (in %) of Kenya per year?
Provide a succinct answer. 39.86. What is the average ODA received (in %) in Kuwait per year?
Make the answer very short. 0.18. What is the average ODA received (in %) of Mongolia per year?
Your answer should be compact. 1.65. What is the average ODA received (in %) of Rwanda per year?
Your answer should be compact. 76.62. In the year 1984, what is the difference between the ODA received (in %) of Kenya and ODA received (in %) of Kuwait?
Make the answer very short. 33.2. In the year 1984, what is the difference between the ODA received (in %) in Kenya and ODA received (in %) in Mongolia?
Offer a terse response. 33.12. In the year 1984, what is the difference between the ODA received (in %) of Kenya and ODA received (in %) of Rwanda?
Your response must be concise. -31.58. In the year 1984, what is the difference between the ODA received (in %) of Kuwait and ODA received (in %) of Mongolia?
Offer a very short reply. -0.08. In the year 1984, what is the difference between the ODA received (in %) in Kuwait and ODA received (in %) in Rwanda?
Keep it short and to the point. -64.78. In the year 1984, what is the difference between the ODA received (in %) in Mongolia and ODA received (in %) in Rwanda?
Offer a terse response. -64.7. In the year 1985, what is the difference between the ODA received (in %) of Kenya and ODA received (in %) of Kuwait?
Your answer should be very brief. 27.36. In the year 1985, what is the difference between the ODA received (in %) of Kenya and ODA received (in %) of Mongolia?
Offer a terse response. 27.08. In the year 1985, what is the difference between the ODA received (in %) of Kenya and ODA received (in %) of Rwanda?
Offer a very short reply. -32.02. In the year 1985, what is the difference between the ODA received (in %) in Kuwait and ODA received (in %) in Mongolia?
Your response must be concise. -0.27. In the year 1985, what is the difference between the ODA received (in %) of Kuwait and ODA received (in %) of Rwanda?
Offer a terse response. -59.37. In the year 1985, what is the difference between the ODA received (in %) of Mongolia and ODA received (in %) of Rwanda?
Give a very brief answer. -59.1. In the year 1986, what is the difference between the ODA received (in %) of Kenya and ODA received (in %) of Kuwait?
Provide a succinct answer. 27.98. In the year 1986, what is the difference between the ODA received (in %) of Kenya and ODA received (in %) of Mongolia?
Provide a short and direct response. 27.76. In the year 1986, what is the difference between the ODA received (in %) in Kenya and ODA received (in %) in Rwanda?
Provide a succinct answer. -38.3. In the year 1986, what is the difference between the ODA received (in %) in Kuwait and ODA received (in %) in Mongolia?
Provide a succinct answer. -0.23. In the year 1986, what is the difference between the ODA received (in %) of Kuwait and ODA received (in %) of Rwanda?
Offer a very short reply. -66.29. In the year 1986, what is the difference between the ODA received (in %) of Mongolia and ODA received (in %) of Rwanda?
Your answer should be very brief. -66.06. In the year 1987, what is the difference between the ODA received (in %) of Kenya and ODA received (in %) of Kuwait?
Provide a short and direct response. 28.69. In the year 1987, what is the difference between the ODA received (in %) of Kenya and ODA received (in %) of Mongolia?
Ensure brevity in your answer.  28.48. In the year 1987, what is the difference between the ODA received (in %) of Kenya and ODA received (in %) of Rwanda?
Offer a very short reply. -41.93. In the year 1987, what is the difference between the ODA received (in %) of Kuwait and ODA received (in %) of Mongolia?
Your response must be concise. -0.22. In the year 1987, what is the difference between the ODA received (in %) of Kuwait and ODA received (in %) of Rwanda?
Offer a terse response. -70.62. In the year 1987, what is the difference between the ODA received (in %) of Mongolia and ODA received (in %) of Rwanda?
Provide a succinct answer. -70.41. In the year 1988, what is the difference between the ODA received (in %) of Kenya and ODA received (in %) of Kuwait?
Offer a very short reply. 38.95. In the year 1988, what is the difference between the ODA received (in %) in Kenya and ODA received (in %) in Mongolia?
Ensure brevity in your answer.  38.87. In the year 1988, what is the difference between the ODA received (in %) of Kenya and ODA received (in %) of Rwanda?
Keep it short and to the point. -31.42. In the year 1988, what is the difference between the ODA received (in %) of Kuwait and ODA received (in %) of Mongolia?
Offer a very short reply. -0.07. In the year 1988, what is the difference between the ODA received (in %) of Kuwait and ODA received (in %) of Rwanda?
Offer a terse response. -70.36. In the year 1988, what is the difference between the ODA received (in %) of Mongolia and ODA received (in %) of Rwanda?
Your response must be concise. -70.29. In the year 1989, what is the difference between the ODA received (in %) in Kenya and ODA received (in %) in Kuwait?
Make the answer very short. 51.3. In the year 1989, what is the difference between the ODA received (in %) in Kenya and ODA received (in %) in Mongolia?
Offer a terse response. 51.1. In the year 1989, what is the difference between the ODA received (in %) of Kenya and ODA received (in %) of Rwanda?
Keep it short and to the point. -18.42. In the year 1989, what is the difference between the ODA received (in %) in Kuwait and ODA received (in %) in Mongolia?
Offer a very short reply. -0.2. In the year 1989, what is the difference between the ODA received (in %) in Kuwait and ODA received (in %) in Rwanda?
Make the answer very short. -69.72. In the year 1989, what is the difference between the ODA received (in %) in Mongolia and ODA received (in %) in Rwanda?
Keep it short and to the point. -69.52. In the year 1990, what is the difference between the ODA received (in %) of Kenya and ODA received (in %) of Kuwait?
Your answer should be very brief. 56.63. In the year 1990, what is the difference between the ODA received (in %) of Kenya and ODA received (in %) of Mongolia?
Provide a succinct answer. 55.27. In the year 1990, what is the difference between the ODA received (in %) of Kenya and ODA received (in %) of Rwanda?
Offer a very short reply. -20.04. In the year 1990, what is the difference between the ODA received (in %) in Kuwait and ODA received (in %) in Mongolia?
Ensure brevity in your answer.  -1.36. In the year 1990, what is the difference between the ODA received (in %) in Kuwait and ODA received (in %) in Rwanda?
Offer a very short reply. -76.67. In the year 1990, what is the difference between the ODA received (in %) in Mongolia and ODA received (in %) in Rwanda?
Give a very brief answer. -75.31. In the year 1991, what is the difference between the ODA received (in %) in Kenya and ODA received (in %) in Kuwait?
Offer a terse response. 53.36. In the year 1991, what is the difference between the ODA received (in %) of Kenya and ODA received (in %) of Mongolia?
Provide a short and direct response. 44.02. In the year 1991, what is the difference between the ODA received (in %) in Kenya and ODA received (in %) in Rwanda?
Provide a succinct answer. -80.38. In the year 1991, what is the difference between the ODA received (in %) in Kuwait and ODA received (in %) in Mongolia?
Offer a very short reply. -9.33. In the year 1991, what is the difference between the ODA received (in %) of Kuwait and ODA received (in %) of Rwanda?
Your response must be concise. -133.74. In the year 1991, what is the difference between the ODA received (in %) of Mongolia and ODA received (in %) of Rwanda?
Your answer should be compact. -124.41. What is the ratio of the ODA received (in %) of Kenya in 1984 to that in 1985?
Provide a short and direct response. 1.21. What is the ratio of the ODA received (in %) in Kuwait in 1984 to that in 1985?
Offer a terse response. 0.94. What is the ratio of the ODA received (in %) in Mongolia in 1984 to that in 1985?
Keep it short and to the point. 0.46. What is the ratio of the ODA received (in %) of Rwanda in 1984 to that in 1985?
Your answer should be compact. 1.09. What is the ratio of the ODA received (in %) of Kenya in 1984 to that in 1986?
Keep it short and to the point. 1.18. What is the ratio of the ODA received (in %) of Kuwait in 1984 to that in 1986?
Provide a short and direct response. 0.78. What is the ratio of the ODA received (in %) in Mongolia in 1984 to that in 1986?
Offer a very short reply. 0.5. What is the ratio of the ODA received (in %) in Rwanda in 1984 to that in 1986?
Ensure brevity in your answer.  0.98. What is the ratio of the ODA received (in %) of Kenya in 1984 to that in 1987?
Make the answer very short. 1.16. What is the ratio of the ODA received (in %) of Kuwait in 1984 to that in 1987?
Your response must be concise. 1.13. What is the ratio of the ODA received (in %) of Mongolia in 1984 to that in 1987?
Provide a short and direct response. 0.57. What is the ratio of the ODA received (in %) in Rwanda in 1984 to that in 1987?
Make the answer very short. 0.92. What is the ratio of the ODA received (in %) of Kenya in 1984 to that in 1988?
Your response must be concise. 0.85. What is the ratio of the ODA received (in %) of Kuwait in 1984 to that in 1988?
Ensure brevity in your answer.  0.54. What is the ratio of the ODA received (in %) in Mongolia in 1984 to that in 1988?
Provide a short and direct response. 0.68. What is the ratio of the ODA received (in %) in Rwanda in 1984 to that in 1988?
Provide a short and direct response. 0.92. What is the ratio of the ODA received (in %) of Kenya in 1984 to that in 1989?
Provide a short and direct response. 0.65. What is the ratio of the ODA received (in %) in Kuwait in 1984 to that in 1989?
Your answer should be compact. 0.62. What is the ratio of the ODA received (in %) in Mongolia in 1984 to that in 1989?
Offer a very short reply. 0.49. What is the ratio of the ODA received (in %) of Rwanda in 1984 to that in 1989?
Offer a terse response. 0.93. What is the ratio of the ODA received (in %) of Kenya in 1984 to that in 1990?
Make the answer very short. 0.58. What is the ratio of the ODA received (in %) in Kuwait in 1984 to that in 1990?
Provide a short and direct response. 0.25. What is the ratio of the ODA received (in %) of Mongolia in 1984 to that in 1990?
Offer a very short reply. 0.1. What is the ratio of the ODA received (in %) of Rwanda in 1984 to that in 1990?
Make the answer very short. 0.84. What is the ratio of the ODA received (in %) of Kenya in 1984 to that in 1991?
Offer a very short reply. 0.62. What is the ratio of the ODA received (in %) in Kuwait in 1984 to that in 1991?
Make the answer very short. 0.38. What is the ratio of the ODA received (in %) in Mongolia in 1984 to that in 1991?
Offer a very short reply. 0.02. What is the ratio of the ODA received (in %) of Rwanda in 1984 to that in 1991?
Make the answer very short. 0.48. What is the ratio of the ODA received (in %) of Kenya in 1985 to that in 1986?
Your answer should be compact. 0.98. What is the ratio of the ODA received (in %) of Kuwait in 1985 to that in 1986?
Offer a terse response. 0.83. What is the ratio of the ODA received (in %) of Mongolia in 1985 to that in 1986?
Provide a short and direct response. 1.07. What is the ratio of the ODA received (in %) of Rwanda in 1985 to that in 1986?
Make the answer very short. 0.9. What is the ratio of the ODA received (in %) of Kenya in 1985 to that in 1987?
Provide a short and direct response. 0.95. What is the ratio of the ODA received (in %) of Kuwait in 1985 to that in 1987?
Keep it short and to the point. 1.21. What is the ratio of the ODA received (in %) in Mongolia in 1985 to that in 1987?
Provide a succinct answer. 1.24. What is the ratio of the ODA received (in %) in Rwanda in 1985 to that in 1987?
Offer a terse response. 0.84. What is the ratio of the ODA received (in %) in Kenya in 1985 to that in 1988?
Offer a terse response. 0.7. What is the ratio of the ODA received (in %) in Kuwait in 1985 to that in 1988?
Offer a very short reply. 0.57. What is the ratio of the ODA received (in %) of Mongolia in 1985 to that in 1988?
Your answer should be very brief. 1.47. What is the ratio of the ODA received (in %) in Rwanda in 1985 to that in 1988?
Your response must be concise. 0.84. What is the ratio of the ODA received (in %) in Kenya in 1985 to that in 1989?
Your answer should be compact. 0.53. What is the ratio of the ODA received (in %) in Kuwait in 1985 to that in 1989?
Provide a succinct answer. 0.66. What is the ratio of the ODA received (in %) of Mongolia in 1985 to that in 1989?
Ensure brevity in your answer.  1.06. What is the ratio of the ODA received (in %) of Rwanda in 1985 to that in 1989?
Ensure brevity in your answer.  0.85. What is the ratio of the ODA received (in %) in Kenya in 1985 to that in 1990?
Offer a very short reply. 0.48. What is the ratio of the ODA received (in %) of Kuwait in 1985 to that in 1990?
Your answer should be very brief. 0.26. What is the ratio of the ODA received (in %) in Mongolia in 1985 to that in 1990?
Offer a very short reply. 0.21. What is the ratio of the ODA received (in %) of Rwanda in 1985 to that in 1990?
Your answer should be compact. 0.77. What is the ratio of the ODA received (in %) in Kenya in 1985 to that in 1991?
Give a very brief answer. 0.51. What is the ratio of the ODA received (in %) of Kuwait in 1985 to that in 1991?
Your response must be concise. 0.41. What is the ratio of the ODA received (in %) of Mongolia in 1985 to that in 1991?
Provide a succinct answer. 0.04. What is the ratio of the ODA received (in %) of Rwanda in 1985 to that in 1991?
Your response must be concise. 0.44. What is the ratio of the ODA received (in %) of Kenya in 1986 to that in 1987?
Make the answer very short. 0.98. What is the ratio of the ODA received (in %) in Kuwait in 1986 to that in 1987?
Offer a terse response. 1.45. What is the ratio of the ODA received (in %) in Mongolia in 1986 to that in 1987?
Provide a short and direct response. 1.16. What is the ratio of the ODA received (in %) of Rwanda in 1986 to that in 1987?
Provide a short and direct response. 0.94. What is the ratio of the ODA received (in %) in Kenya in 1986 to that in 1988?
Ensure brevity in your answer.  0.72. What is the ratio of the ODA received (in %) in Kuwait in 1986 to that in 1988?
Keep it short and to the point. 0.69. What is the ratio of the ODA received (in %) of Mongolia in 1986 to that in 1988?
Give a very brief answer. 1.38. What is the ratio of the ODA received (in %) in Rwanda in 1986 to that in 1988?
Your answer should be very brief. 0.94. What is the ratio of the ODA received (in %) of Kenya in 1986 to that in 1989?
Ensure brevity in your answer.  0.55. What is the ratio of the ODA received (in %) of Kuwait in 1986 to that in 1989?
Your answer should be very brief. 0.79. What is the ratio of the ODA received (in %) of Rwanda in 1986 to that in 1989?
Ensure brevity in your answer.  0.95. What is the ratio of the ODA received (in %) of Kenya in 1986 to that in 1990?
Your answer should be compact. 0.49. What is the ratio of the ODA received (in %) of Kuwait in 1986 to that in 1990?
Your response must be concise. 0.32. What is the ratio of the ODA received (in %) in Mongolia in 1986 to that in 1990?
Your answer should be compact. 0.2. What is the ratio of the ODA received (in %) in Rwanda in 1986 to that in 1990?
Keep it short and to the point. 0.86. What is the ratio of the ODA received (in %) of Kenya in 1986 to that in 1991?
Provide a succinct answer. 0.52. What is the ratio of the ODA received (in %) in Kuwait in 1986 to that in 1991?
Provide a succinct answer. 0.49. What is the ratio of the ODA received (in %) in Mongolia in 1986 to that in 1991?
Offer a very short reply. 0.04. What is the ratio of the ODA received (in %) in Rwanda in 1986 to that in 1991?
Offer a terse response. 0.5. What is the ratio of the ODA received (in %) in Kenya in 1987 to that in 1988?
Your response must be concise. 0.74. What is the ratio of the ODA received (in %) in Kuwait in 1987 to that in 1988?
Your answer should be very brief. 0.47. What is the ratio of the ODA received (in %) of Mongolia in 1987 to that in 1988?
Your answer should be very brief. 1.19. What is the ratio of the ODA received (in %) in Rwanda in 1987 to that in 1988?
Provide a short and direct response. 1. What is the ratio of the ODA received (in %) of Kenya in 1987 to that in 1989?
Your answer should be compact. 0.56. What is the ratio of the ODA received (in %) of Kuwait in 1987 to that in 1989?
Make the answer very short. 0.55. What is the ratio of the ODA received (in %) of Mongolia in 1987 to that in 1989?
Give a very brief answer. 0.86. What is the ratio of the ODA received (in %) in Rwanda in 1987 to that in 1989?
Your answer should be very brief. 1.01. What is the ratio of the ODA received (in %) of Kenya in 1987 to that in 1990?
Your response must be concise. 0.5. What is the ratio of the ODA received (in %) in Kuwait in 1987 to that in 1990?
Ensure brevity in your answer.  0.22. What is the ratio of the ODA received (in %) of Mongolia in 1987 to that in 1990?
Make the answer very short. 0.17. What is the ratio of the ODA received (in %) of Rwanda in 1987 to that in 1990?
Ensure brevity in your answer.  0.92. What is the ratio of the ODA received (in %) in Kenya in 1987 to that in 1991?
Provide a succinct answer. 0.54. What is the ratio of the ODA received (in %) of Kuwait in 1987 to that in 1991?
Offer a terse response. 0.34. What is the ratio of the ODA received (in %) in Mongolia in 1987 to that in 1991?
Give a very brief answer. 0.03. What is the ratio of the ODA received (in %) in Rwanda in 1987 to that in 1991?
Your answer should be compact. 0.53. What is the ratio of the ODA received (in %) in Kenya in 1988 to that in 1989?
Offer a very short reply. 0.76. What is the ratio of the ODA received (in %) in Kuwait in 1988 to that in 1989?
Keep it short and to the point. 1.16. What is the ratio of the ODA received (in %) in Mongolia in 1988 to that in 1989?
Offer a very short reply. 0.72. What is the ratio of the ODA received (in %) in Rwanda in 1988 to that in 1989?
Provide a short and direct response. 1.01. What is the ratio of the ODA received (in %) in Kenya in 1988 to that in 1990?
Make the answer very short. 0.69. What is the ratio of the ODA received (in %) of Kuwait in 1988 to that in 1990?
Your answer should be compact. 0.46. What is the ratio of the ODA received (in %) in Mongolia in 1988 to that in 1990?
Provide a short and direct response. 0.15. What is the ratio of the ODA received (in %) in Rwanda in 1988 to that in 1990?
Offer a very short reply. 0.92. What is the ratio of the ODA received (in %) of Kenya in 1988 to that in 1991?
Your answer should be very brief. 0.73. What is the ratio of the ODA received (in %) of Kuwait in 1988 to that in 1991?
Provide a short and direct response. 0.72. What is the ratio of the ODA received (in %) of Mongolia in 1988 to that in 1991?
Offer a very short reply. 0.03. What is the ratio of the ODA received (in %) in Rwanda in 1988 to that in 1991?
Your answer should be very brief. 0.53. What is the ratio of the ODA received (in %) in Kenya in 1989 to that in 1990?
Provide a succinct answer. 0.9. What is the ratio of the ODA received (in %) of Kuwait in 1989 to that in 1990?
Provide a succinct answer. 0.4. What is the ratio of the ODA received (in %) of Mongolia in 1989 to that in 1990?
Your answer should be compact. 0.2. What is the ratio of the ODA received (in %) in Rwanda in 1989 to that in 1990?
Offer a terse response. 0.91. What is the ratio of the ODA received (in %) of Kenya in 1989 to that in 1991?
Make the answer very short. 0.96. What is the ratio of the ODA received (in %) of Kuwait in 1989 to that in 1991?
Keep it short and to the point. 0.62. What is the ratio of the ODA received (in %) of Mongolia in 1989 to that in 1991?
Give a very brief answer. 0.04. What is the ratio of the ODA received (in %) of Rwanda in 1989 to that in 1991?
Make the answer very short. 0.52. What is the ratio of the ODA received (in %) in Kenya in 1990 to that in 1991?
Offer a very short reply. 1.06. What is the ratio of the ODA received (in %) of Kuwait in 1990 to that in 1991?
Provide a short and direct response. 1.55. What is the ratio of the ODA received (in %) of Mongolia in 1990 to that in 1991?
Your response must be concise. 0.18. What is the ratio of the ODA received (in %) of Rwanda in 1990 to that in 1991?
Your answer should be very brief. 0.58. What is the difference between the highest and the second highest ODA received (in %) of Kenya?
Provide a succinct answer. 3.41. What is the difference between the highest and the second highest ODA received (in %) in Kuwait?
Ensure brevity in your answer.  0.14. What is the difference between the highest and the second highest ODA received (in %) in Mongolia?
Keep it short and to the point. 7.84. What is the difference between the highest and the second highest ODA received (in %) in Rwanda?
Give a very brief answer. 56.93. What is the difference between the highest and the lowest ODA received (in %) of Kenya?
Offer a very short reply. 29.57. What is the difference between the highest and the lowest ODA received (in %) of Kuwait?
Your response must be concise. 0.31. What is the difference between the highest and the lowest ODA received (in %) of Mongolia?
Your response must be concise. 9.41. What is the difference between the highest and the lowest ODA received (in %) in Rwanda?
Keep it short and to the point. 74.52. 